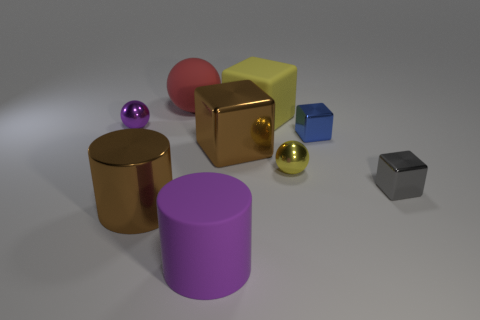Is the number of cylinders that are behind the large red matte object greater than the number of big blue matte blocks?
Keep it short and to the point. No. Is the shape of the big red rubber object the same as the small metal thing that is on the left side of the yellow rubber thing?
Offer a very short reply. Yes. Are any big red matte balls visible?
Offer a terse response. Yes. How many big things are yellow rubber things or blue cubes?
Ensure brevity in your answer.  1. Are there more small purple metallic things that are behind the matte cube than small metal balls to the left of the gray shiny thing?
Provide a short and direct response. No. Do the small gray thing and the purple object behind the large brown metallic cylinder have the same material?
Your response must be concise. Yes. The large matte sphere has what color?
Your answer should be compact. Red. What shape is the big brown shiny thing that is right of the large red matte sphere?
Provide a short and direct response. Cube. What number of cyan things are tiny spheres or metallic objects?
Keep it short and to the point. 0. What color is the big cube that is made of the same material as the red ball?
Offer a very short reply. Yellow. 